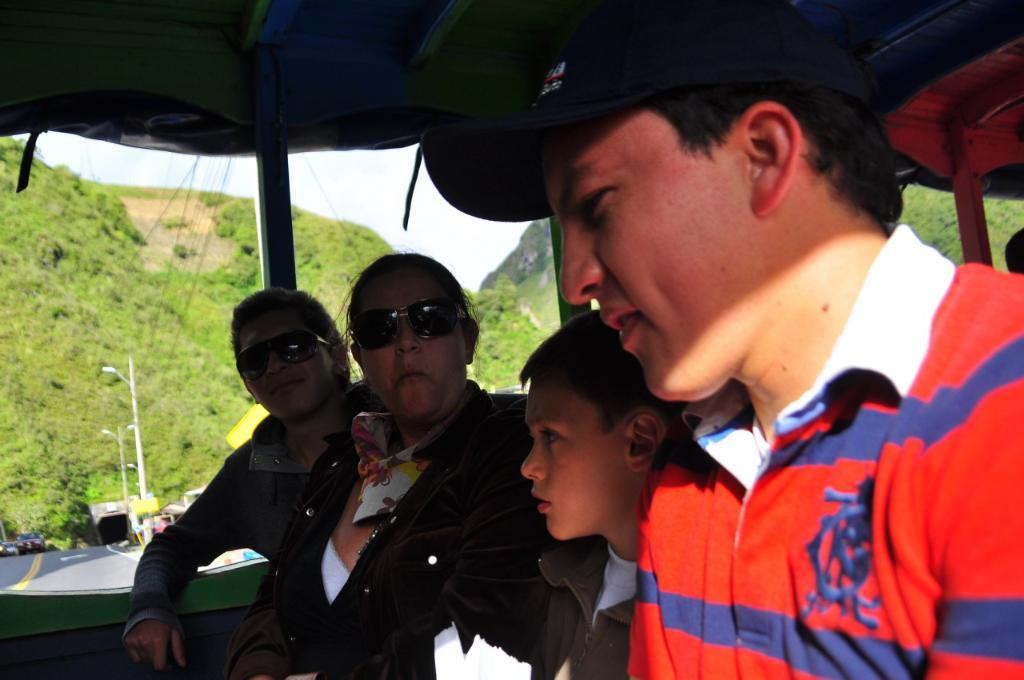How many people are in the image? There are four members in the image. Can you describe any accessories worn by the members? Two of the members are wearing spectacles, and one member is wearing a cap on their head. What can be seen in the background of the image? There are hills and the sky visible in the background of the image. What type of fowl can be seen flying over the hills in the image? There is no fowl visible in the image; only the hills and sky are present in the background. Is there an airport visible in the image? There is no airport present in the image; the focus is on the members and the background elements. 